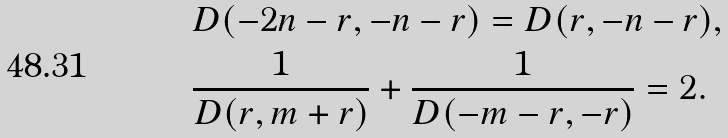Convert formula to latex. <formula><loc_0><loc_0><loc_500><loc_500>& D ( - 2 n - r , - n - r ) = D ( r , - n - r ) , \\ & \frac { 1 } { D ( r , m + r ) } + \frac { 1 } { D ( - m - r , - r ) } = 2 .</formula> 